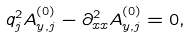Convert formula to latex. <formula><loc_0><loc_0><loc_500><loc_500>q _ { j } ^ { 2 } A _ { y , j } ^ { ( 0 ) } - \partial _ { x x } ^ { 2 } A _ { y , j } ^ { ( 0 ) } = 0 ,</formula> 